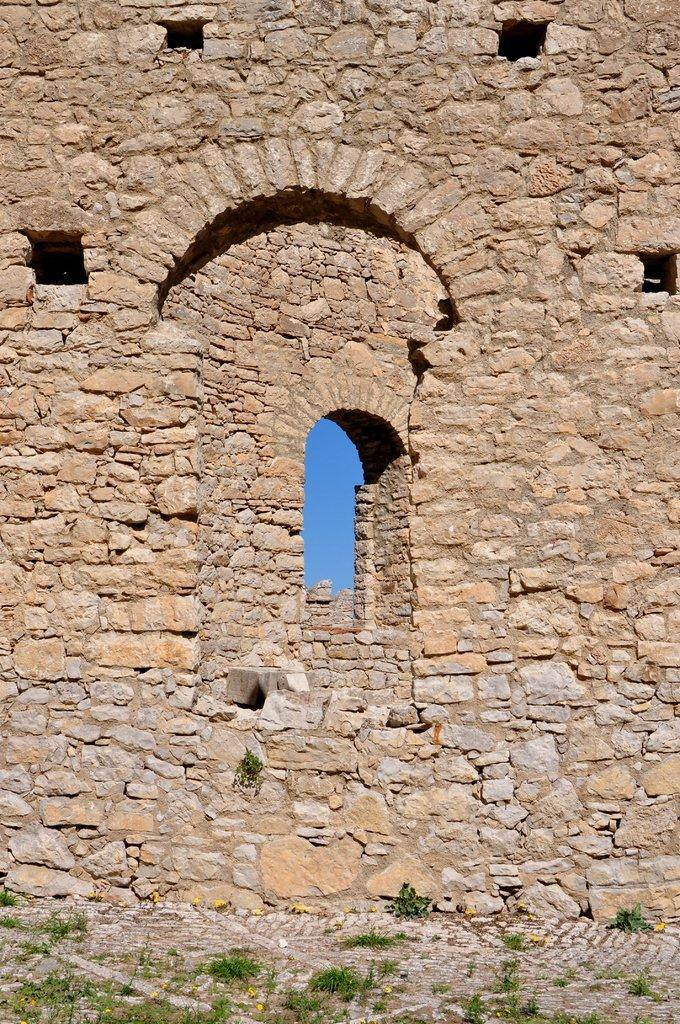What type of structure is present in the image? There is a stone wall in the image. What else can be seen at the bottom of the image? There are plants at the bottom of the image. What is visible in the background of the image? The sky is visible in the background of the image. What type of wax is being used to trip over the stone wall in the image? There is no wax or tripping incident present in the image; it features a stone wall and plants. 